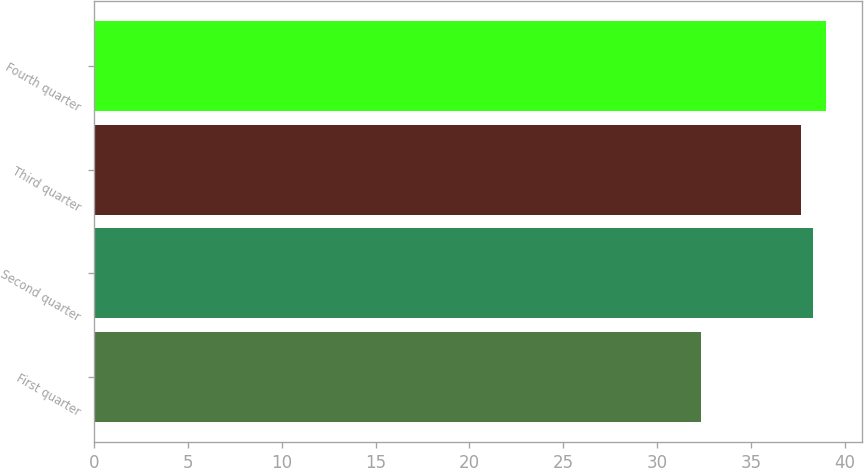<chart> <loc_0><loc_0><loc_500><loc_500><bar_chart><fcel>First quarter<fcel>Second quarter<fcel>Third quarter<fcel>Fourth quarter<nl><fcel>32.37<fcel>38.33<fcel>37.67<fcel>38.99<nl></chart> 